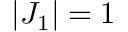<formula> <loc_0><loc_0><loc_500><loc_500>| J _ { 1 } | = 1</formula> 